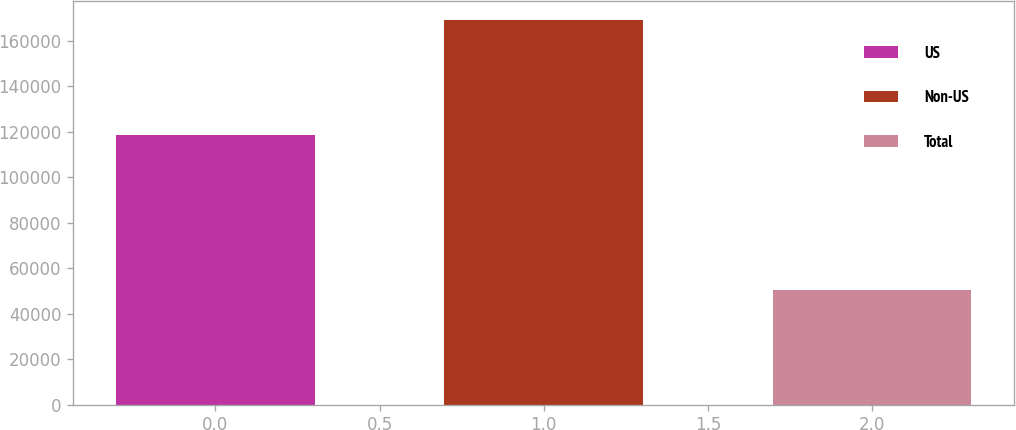<chart> <loc_0><loc_0><loc_500><loc_500><bar_chart><fcel>US<fcel>Non-US<fcel>Total<nl><fcel>118546<fcel>169133<fcel>50587<nl></chart> 